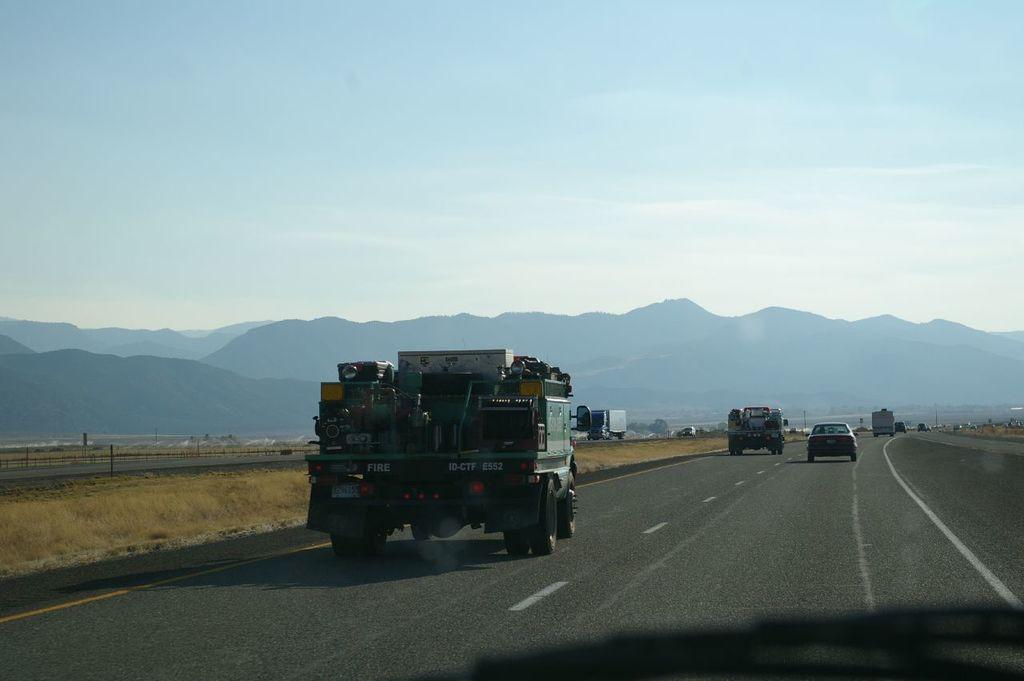Describe this image in one or two sentences. In this image we can see group of vehicles parked on the road. In the background, we can see mountains and the sky. 